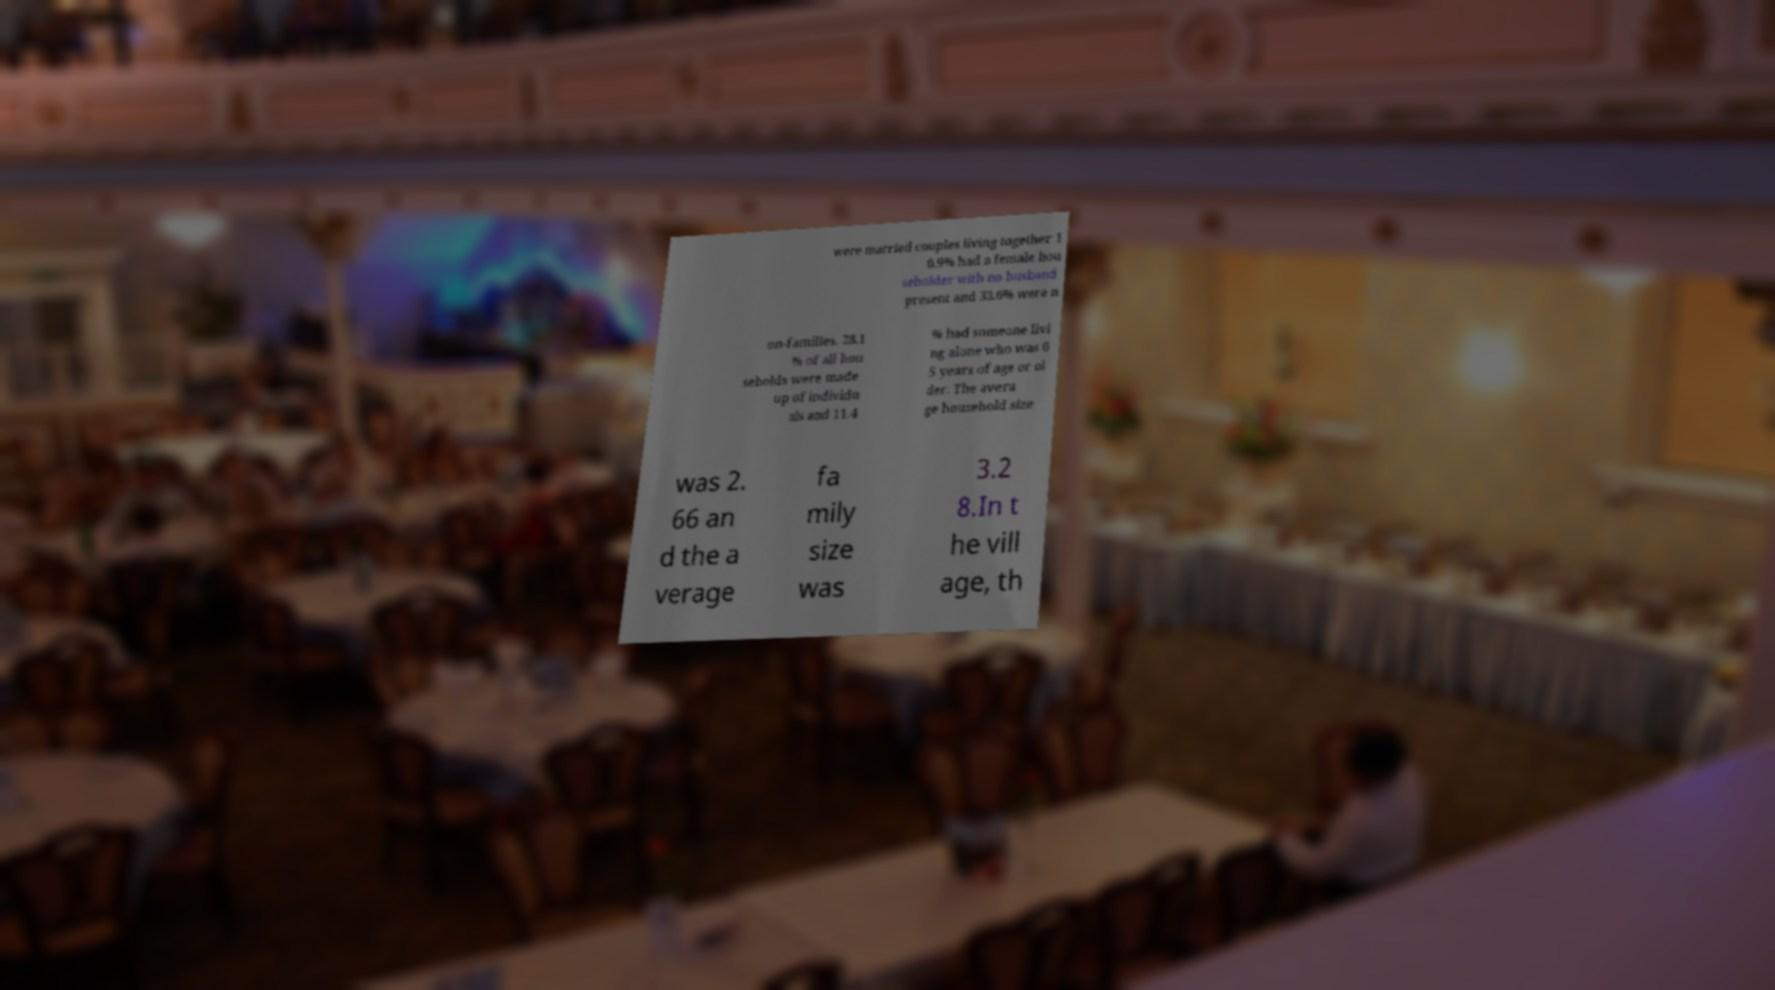What messages or text are displayed in this image? I need them in a readable, typed format. were married couples living together 1 0.9% had a female hou seholder with no husband present and 33.6% were n on-families. 28.1 % of all hou seholds were made up of individu als and 11.4 % had someone livi ng alone who was 6 5 years of age or ol der. The avera ge household size was 2. 66 an d the a verage fa mily size was 3.2 8.In t he vill age, th 